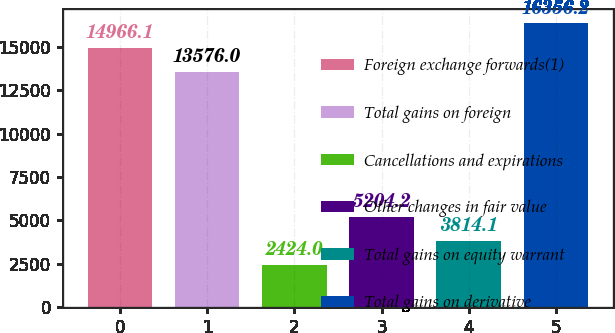<chart> <loc_0><loc_0><loc_500><loc_500><bar_chart><fcel>Foreign exchange forwards(1)<fcel>Total gains on foreign<fcel>Cancellations and expirations<fcel>Other changes in fair value<fcel>Total gains on equity warrant<fcel>Total gains on derivative<nl><fcel>14966.1<fcel>13576<fcel>2424<fcel>5204.2<fcel>3814.1<fcel>16356.2<nl></chart> 